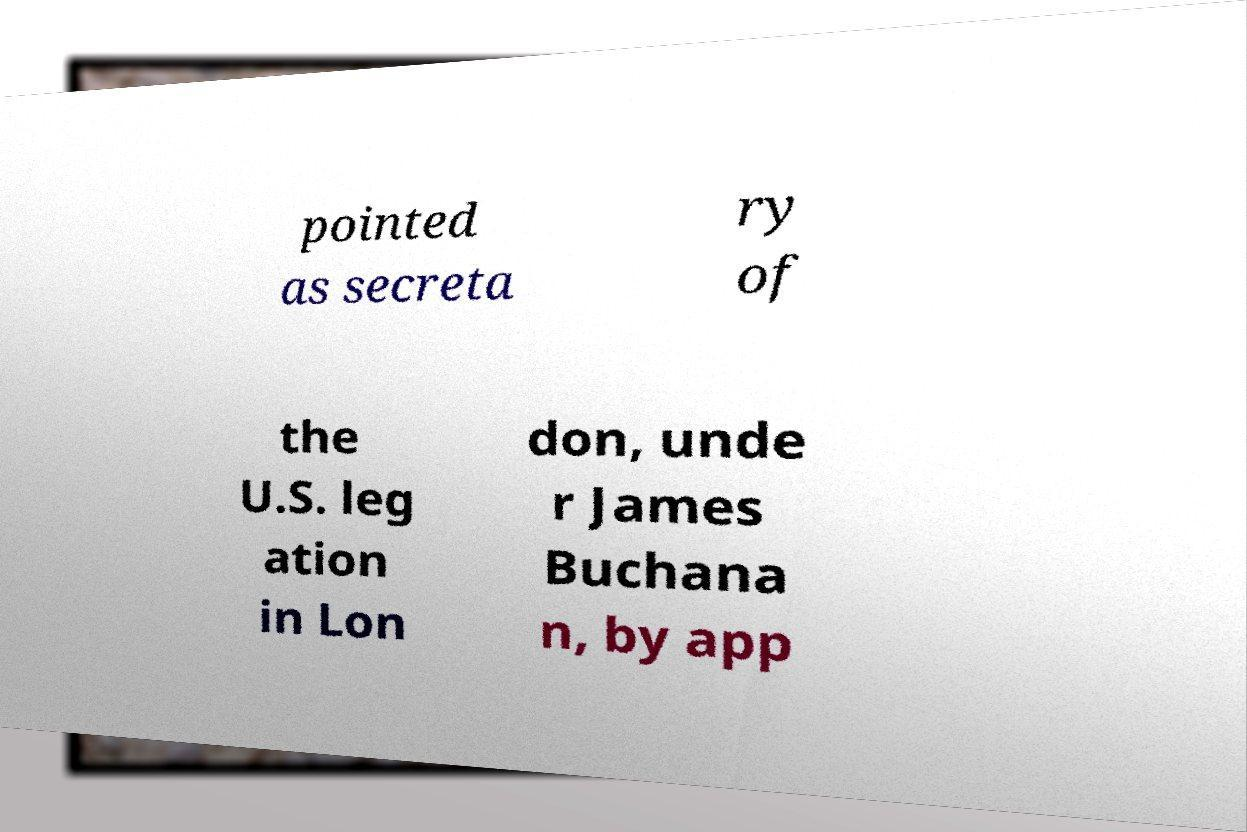I need the written content from this picture converted into text. Can you do that? pointed as secreta ry of the U.S. leg ation in Lon don, unde r James Buchana n, by app 